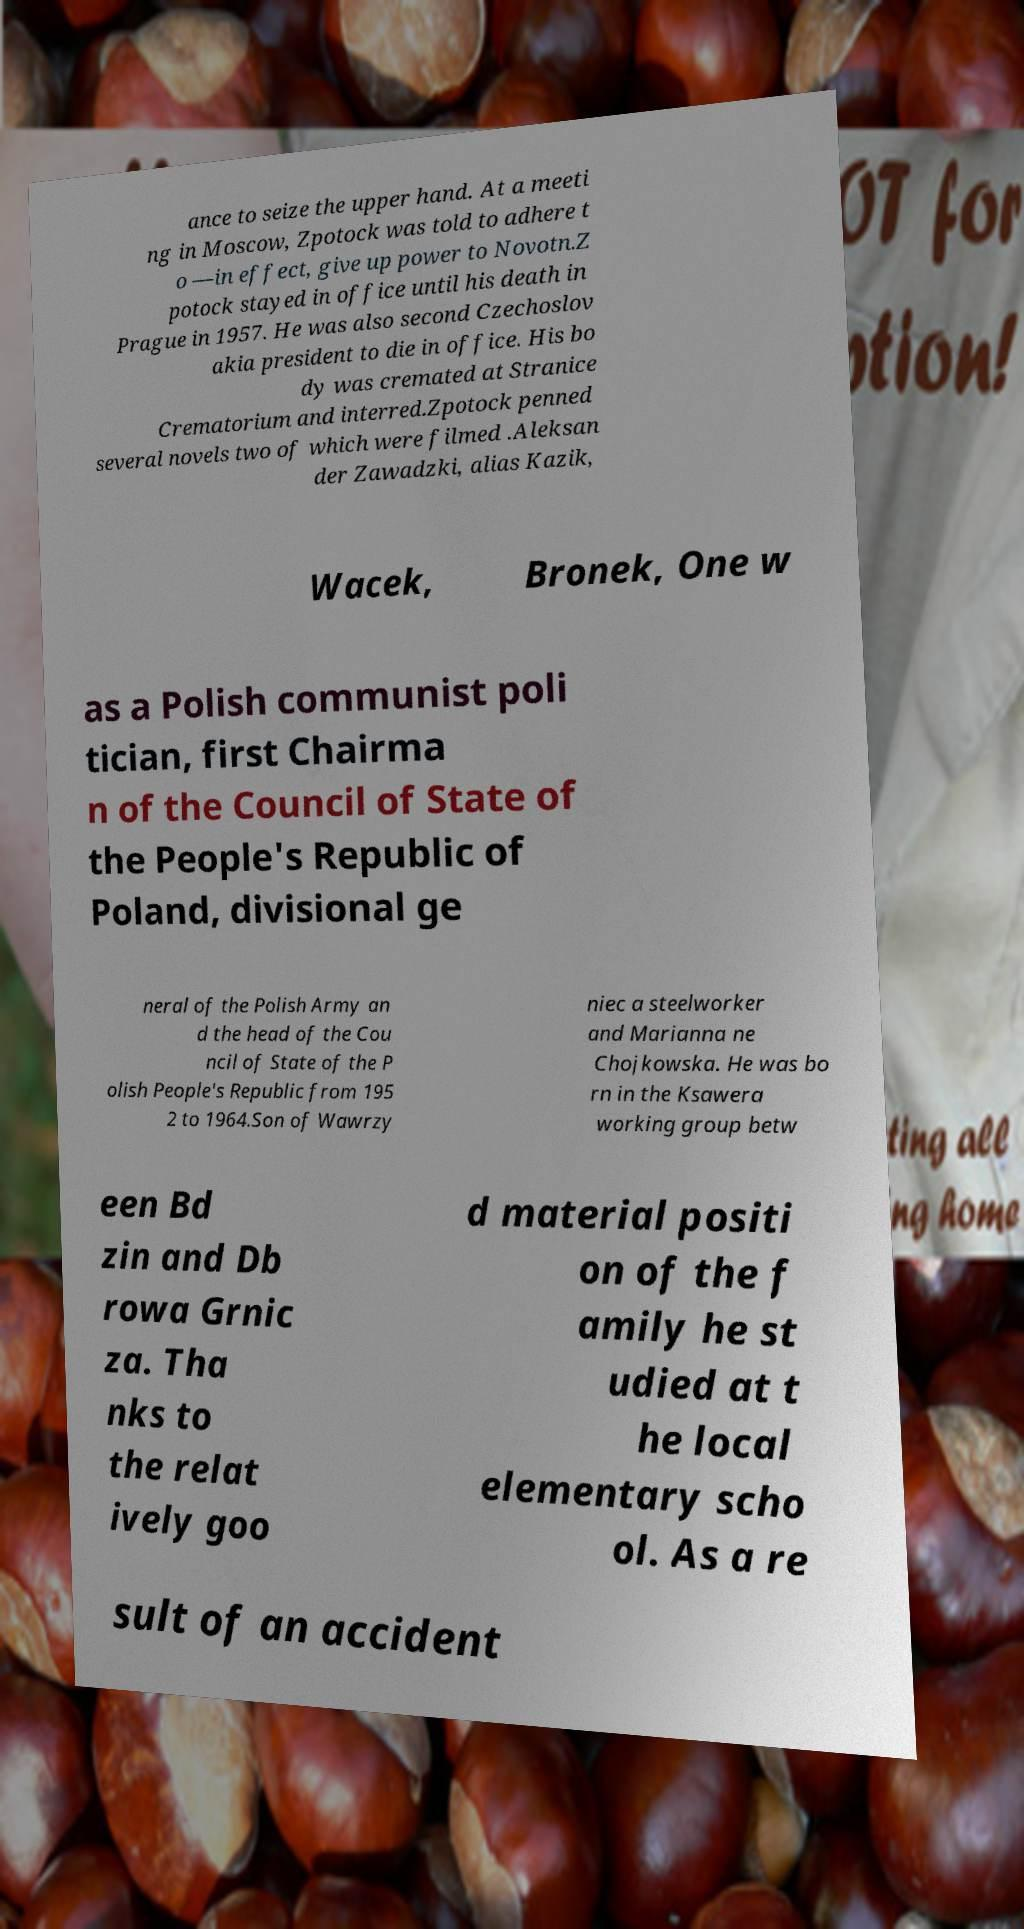Could you assist in decoding the text presented in this image and type it out clearly? ance to seize the upper hand. At a meeti ng in Moscow, Zpotock was told to adhere t o —in effect, give up power to Novotn.Z potock stayed in office until his death in Prague in 1957. He was also second Czechoslov akia president to die in office. His bo dy was cremated at Stranice Crematorium and interred.Zpotock penned several novels two of which were filmed .Aleksan der Zawadzki, alias Kazik, Wacek, Bronek, One w as a Polish communist poli tician, first Chairma n of the Council of State of the People's Republic of Poland, divisional ge neral of the Polish Army an d the head of the Cou ncil of State of the P olish People's Republic from 195 2 to 1964.Son of Wawrzy niec a steelworker and Marianna ne Chojkowska. He was bo rn in the Ksawera working group betw een Bd zin and Db rowa Grnic za. Tha nks to the relat ively goo d material positi on of the f amily he st udied at t he local elementary scho ol. As a re sult of an accident 